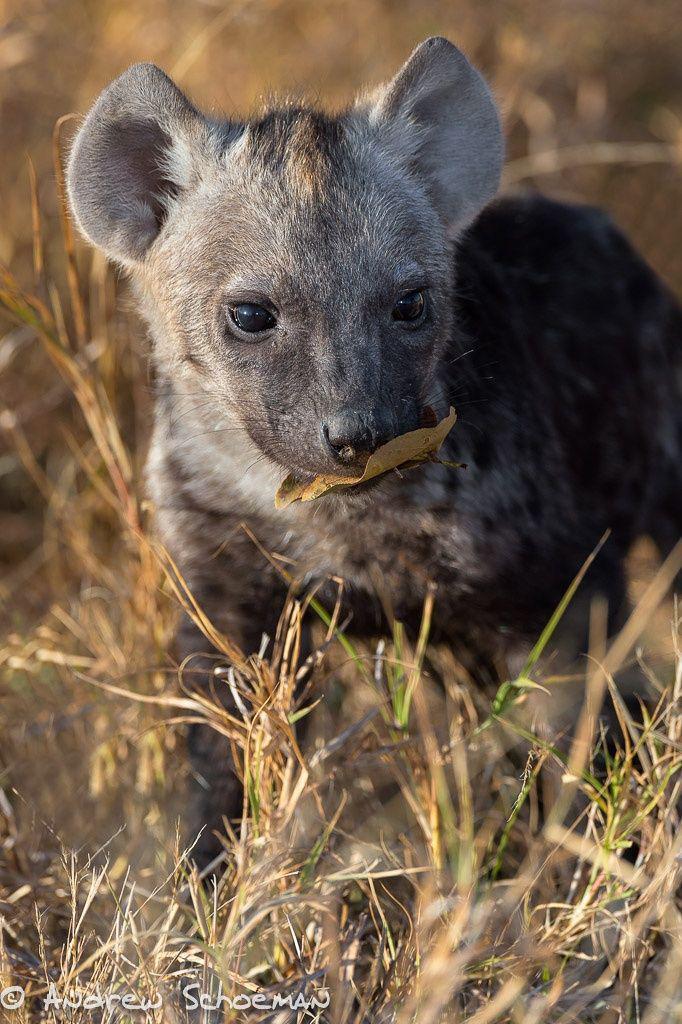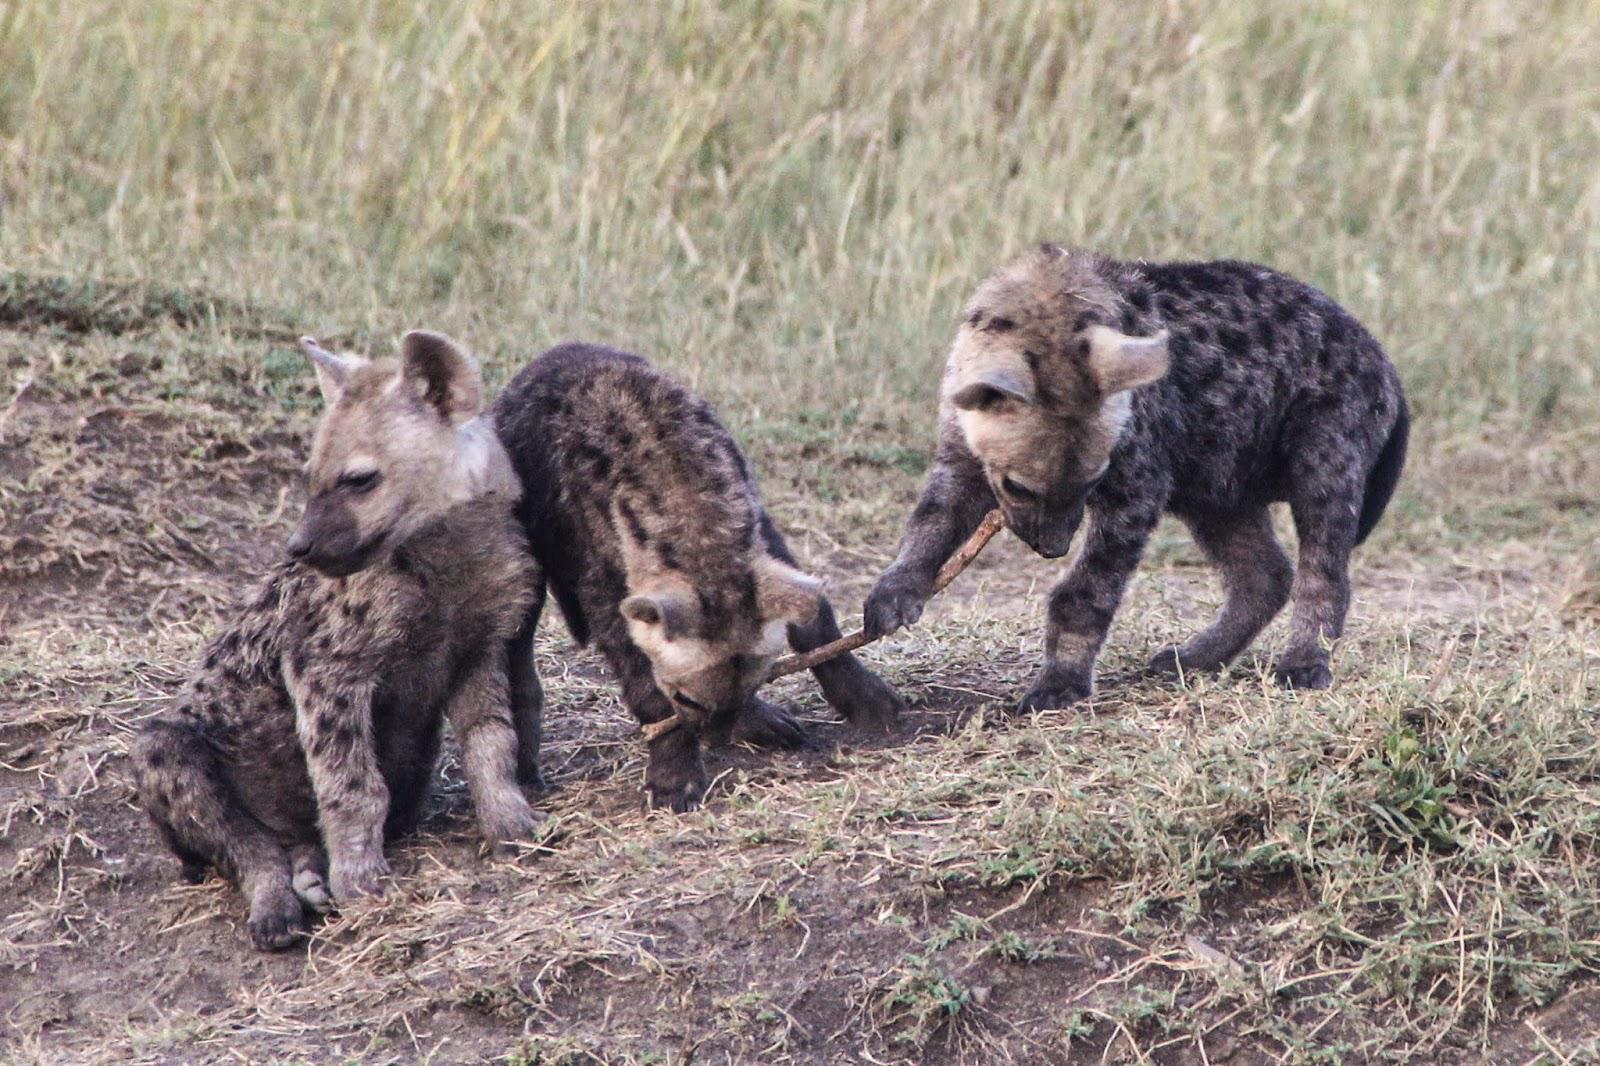The first image is the image on the left, the second image is the image on the right. For the images displayed, is the sentence "At least one image shows an upright young hyena with something that is not part of a prey animal held in its mouth." factually correct? Answer yes or no. Yes. The first image is the image on the left, the second image is the image on the right. Evaluate the accuracy of this statement regarding the images: "The left image contains two hyenas.". Is it true? Answer yes or no. No. 